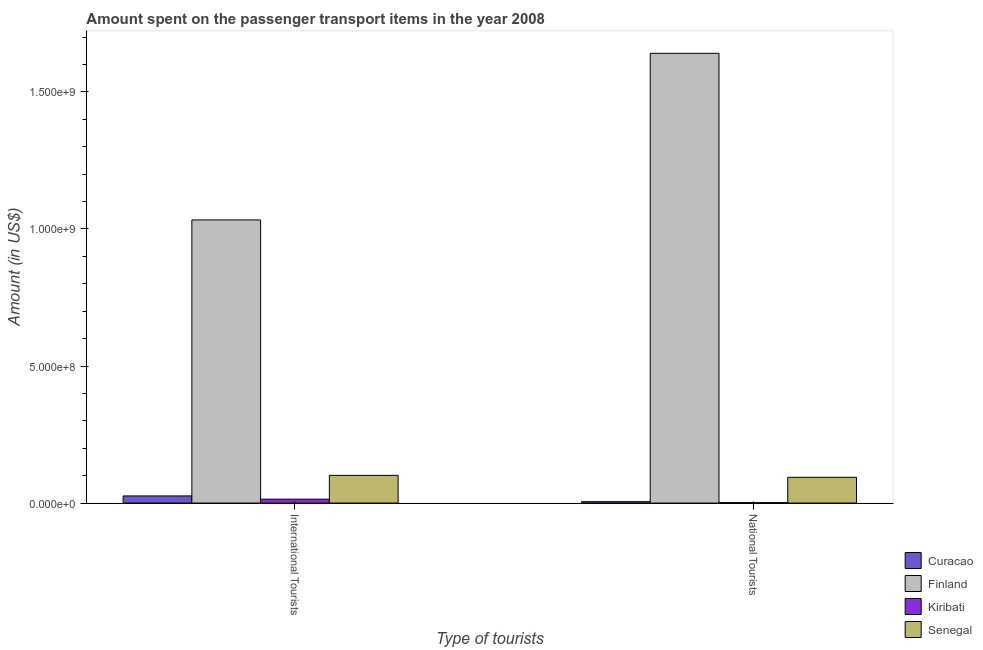How many groups of bars are there?
Provide a succinct answer. 2. How many bars are there on the 2nd tick from the left?
Ensure brevity in your answer.  4. How many bars are there on the 2nd tick from the right?
Keep it short and to the point. 4. What is the label of the 2nd group of bars from the left?
Your response must be concise. National Tourists. What is the amount spent on transport items of national tourists in Senegal?
Provide a short and direct response. 9.40e+07. Across all countries, what is the maximum amount spent on transport items of national tourists?
Keep it short and to the point. 1.64e+09. Across all countries, what is the minimum amount spent on transport items of international tourists?
Keep it short and to the point. 1.41e+07. In which country was the amount spent on transport items of international tourists minimum?
Give a very brief answer. Kiribati. What is the total amount spent on transport items of national tourists in the graph?
Provide a succinct answer. 1.74e+09. What is the difference between the amount spent on transport items of international tourists in Curacao and that in Senegal?
Keep it short and to the point. -7.50e+07. What is the difference between the amount spent on transport items of international tourists in Curacao and the amount spent on transport items of national tourists in Senegal?
Your answer should be compact. -6.80e+07. What is the average amount spent on transport items of international tourists per country?
Provide a succinct answer. 2.94e+08. What is the difference between the amount spent on transport items of international tourists and amount spent on transport items of national tourists in Finland?
Provide a short and direct response. -6.08e+08. In how many countries, is the amount spent on transport items of national tourists greater than 1400000000 US$?
Give a very brief answer. 1. What is the ratio of the amount spent on transport items of national tourists in Curacao to that in Senegal?
Ensure brevity in your answer.  0.05. In how many countries, is the amount spent on transport items of international tourists greater than the average amount spent on transport items of international tourists taken over all countries?
Offer a terse response. 1. What does the 3rd bar from the left in National Tourists represents?
Give a very brief answer. Kiribati. What does the 4th bar from the right in National Tourists represents?
Keep it short and to the point. Curacao. Are the values on the major ticks of Y-axis written in scientific E-notation?
Offer a very short reply. Yes. Does the graph contain grids?
Your response must be concise. No. Where does the legend appear in the graph?
Make the answer very short. Bottom right. What is the title of the graph?
Give a very brief answer. Amount spent on the passenger transport items in the year 2008. Does "Germany" appear as one of the legend labels in the graph?
Provide a short and direct response. No. What is the label or title of the X-axis?
Provide a short and direct response. Type of tourists. What is the label or title of the Y-axis?
Provide a succinct answer. Amount (in US$). What is the Amount (in US$) in Curacao in International Tourists?
Offer a terse response. 2.60e+07. What is the Amount (in US$) in Finland in International Tourists?
Provide a succinct answer. 1.03e+09. What is the Amount (in US$) of Kiribati in International Tourists?
Your response must be concise. 1.41e+07. What is the Amount (in US$) in Senegal in International Tourists?
Provide a short and direct response. 1.01e+08. What is the Amount (in US$) in Curacao in National Tourists?
Keep it short and to the point. 5.00e+06. What is the Amount (in US$) of Finland in National Tourists?
Offer a terse response. 1.64e+09. What is the Amount (in US$) in Kiribati in National Tourists?
Provide a short and direct response. 1.40e+06. What is the Amount (in US$) of Senegal in National Tourists?
Offer a very short reply. 9.40e+07. Across all Type of tourists, what is the maximum Amount (in US$) of Curacao?
Offer a very short reply. 2.60e+07. Across all Type of tourists, what is the maximum Amount (in US$) in Finland?
Make the answer very short. 1.64e+09. Across all Type of tourists, what is the maximum Amount (in US$) in Kiribati?
Your answer should be very brief. 1.41e+07. Across all Type of tourists, what is the maximum Amount (in US$) of Senegal?
Offer a very short reply. 1.01e+08. Across all Type of tourists, what is the minimum Amount (in US$) in Curacao?
Offer a very short reply. 5.00e+06. Across all Type of tourists, what is the minimum Amount (in US$) in Finland?
Offer a very short reply. 1.03e+09. Across all Type of tourists, what is the minimum Amount (in US$) in Kiribati?
Offer a terse response. 1.40e+06. Across all Type of tourists, what is the minimum Amount (in US$) in Senegal?
Provide a short and direct response. 9.40e+07. What is the total Amount (in US$) of Curacao in the graph?
Your response must be concise. 3.10e+07. What is the total Amount (in US$) in Finland in the graph?
Provide a succinct answer. 2.67e+09. What is the total Amount (in US$) in Kiribati in the graph?
Your answer should be very brief. 1.55e+07. What is the total Amount (in US$) in Senegal in the graph?
Provide a succinct answer. 1.95e+08. What is the difference between the Amount (in US$) of Curacao in International Tourists and that in National Tourists?
Ensure brevity in your answer.  2.10e+07. What is the difference between the Amount (in US$) in Finland in International Tourists and that in National Tourists?
Keep it short and to the point. -6.08e+08. What is the difference between the Amount (in US$) in Kiribati in International Tourists and that in National Tourists?
Give a very brief answer. 1.27e+07. What is the difference between the Amount (in US$) of Senegal in International Tourists and that in National Tourists?
Offer a terse response. 7.00e+06. What is the difference between the Amount (in US$) of Curacao in International Tourists and the Amount (in US$) of Finland in National Tourists?
Ensure brevity in your answer.  -1.62e+09. What is the difference between the Amount (in US$) of Curacao in International Tourists and the Amount (in US$) of Kiribati in National Tourists?
Ensure brevity in your answer.  2.46e+07. What is the difference between the Amount (in US$) of Curacao in International Tourists and the Amount (in US$) of Senegal in National Tourists?
Give a very brief answer. -6.80e+07. What is the difference between the Amount (in US$) of Finland in International Tourists and the Amount (in US$) of Kiribati in National Tourists?
Your response must be concise. 1.03e+09. What is the difference between the Amount (in US$) in Finland in International Tourists and the Amount (in US$) in Senegal in National Tourists?
Your answer should be very brief. 9.39e+08. What is the difference between the Amount (in US$) of Kiribati in International Tourists and the Amount (in US$) of Senegal in National Tourists?
Offer a terse response. -7.99e+07. What is the average Amount (in US$) of Curacao per Type of tourists?
Your answer should be compact. 1.55e+07. What is the average Amount (in US$) of Finland per Type of tourists?
Keep it short and to the point. 1.34e+09. What is the average Amount (in US$) of Kiribati per Type of tourists?
Your response must be concise. 7.75e+06. What is the average Amount (in US$) of Senegal per Type of tourists?
Provide a short and direct response. 9.75e+07. What is the difference between the Amount (in US$) in Curacao and Amount (in US$) in Finland in International Tourists?
Make the answer very short. -1.01e+09. What is the difference between the Amount (in US$) of Curacao and Amount (in US$) of Kiribati in International Tourists?
Offer a very short reply. 1.19e+07. What is the difference between the Amount (in US$) in Curacao and Amount (in US$) in Senegal in International Tourists?
Offer a terse response. -7.50e+07. What is the difference between the Amount (in US$) in Finland and Amount (in US$) in Kiribati in International Tourists?
Give a very brief answer. 1.02e+09. What is the difference between the Amount (in US$) of Finland and Amount (in US$) of Senegal in International Tourists?
Ensure brevity in your answer.  9.32e+08. What is the difference between the Amount (in US$) in Kiribati and Amount (in US$) in Senegal in International Tourists?
Ensure brevity in your answer.  -8.69e+07. What is the difference between the Amount (in US$) of Curacao and Amount (in US$) of Finland in National Tourists?
Provide a short and direct response. -1.64e+09. What is the difference between the Amount (in US$) of Curacao and Amount (in US$) of Kiribati in National Tourists?
Provide a succinct answer. 3.60e+06. What is the difference between the Amount (in US$) of Curacao and Amount (in US$) of Senegal in National Tourists?
Provide a short and direct response. -8.90e+07. What is the difference between the Amount (in US$) in Finland and Amount (in US$) in Kiribati in National Tourists?
Offer a terse response. 1.64e+09. What is the difference between the Amount (in US$) in Finland and Amount (in US$) in Senegal in National Tourists?
Provide a short and direct response. 1.55e+09. What is the difference between the Amount (in US$) of Kiribati and Amount (in US$) of Senegal in National Tourists?
Keep it short and to the point. -9.26e+07. What is the ratio of the Amount (in US$) in Curacao in International Tourists to that in National Tourists?
Offer a very short reply. 5.2. What is the ratio of the Amount (in US$) in Finland in International Tourists to that in National Tourists?
Offer a terse response. 0.63. What is the ratio of the Amount (in US$) in Kiribati in International Tourists to that in National Tourists?
Your response must be concise. 10.07. What is the ratio of the Amount (in US$) of Senegal in International Tourists to that in National Tourists?
Ensure brevity in your answer.  1.07. What is the difference between the highest and the second highest Amount (in US$) in Curacao?
Provide a succinct answer. 2.10e+07. What is the difference between the highest and the second highest Amount (in US$) of Finland?
Make the answer very short. 6.08e+08. What is the difference between the highest and the second highest Amount (in US$) in Kiribati?
Offer a very short reply. 1.27e+07. What is the difference between the highest and the lowest Amount (in US$) of Curacao?
Offer a terse response. 2.10e+07. What is the difference between the highest and the lowest Amount (in US$) in Finland?
Offer a very short reply. 6.08e+08. What is the difference between the highest and the lowest Amount (in US$) in Kiribati?
Provide a short and direct response. 1.27e+07. What is the difference between the highest and the lowest Amount (in US$) in Senegal?
Offer a very short reply. 7.00e+06. 